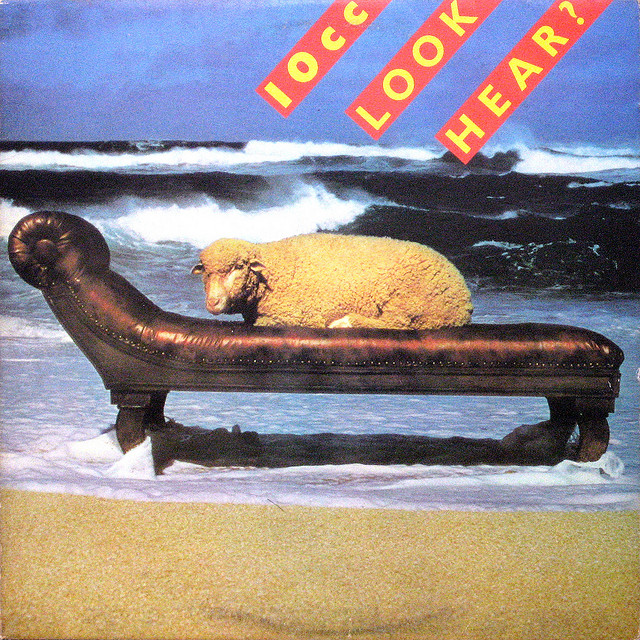<image>What is the name of the chair? I don't know the name of the chair. It can be 'chaise lounge chair', 'locc', 'chaise', 'leather', 'divan', or '10cc'. What is the name of the chair? I am not sure what the name of the chair is. It can be called 'chaise lounge chair', 'locc', 'chaise', 'leather', 'divan', or '10cc'. 